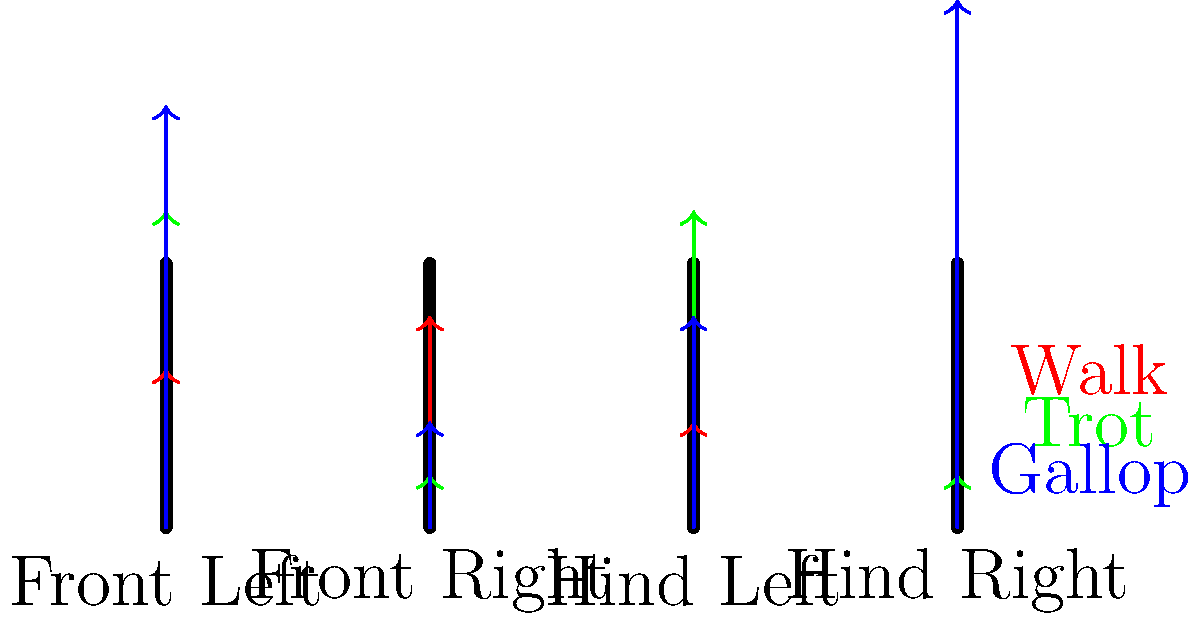As a media professional promoting a renowned jockey, you're tasked with explaining the biomechanics of horse movement to the public. Based on the force vector graphics shown for different gaits (walk, trot, and gallop), which gait places the highest peak force on a single leg, and how might this information be relevant to the jockey's riding strategy? To answer this question, we need to analyze the force vectors for each gait:

1. Walk (red vectors):
   - Forces are relatively evenly distributed across all four legs.
   - Peak force appears to be on the front right leg, but it's not significantly higher than the others.

2. Trot (green vectors):
   - Forces alternate between diagonal pairs of legs.
   - Two legs (front left and hind right) show higher forces, while the other two show lower forces.

3. Gallop (blue vectors):
   - Forces are unevenly distributed, with the highest concentration on the hind right leg.
   - The hind right leg shows the longest vector, indicating the highest peak force among all gaits.

The gallop places the highest peak force on a single leg, specifically the hind right leg. This information is relevant to the jockey's riding strategy for several reasons:

1. Performance: Understanding force distribution helps the jockey optimize the horse's stride and energy expenditure during races.

2. Injury prevention: Knowing which leg experiences the highest force allows the jockey and trainers to pay special attention to that leg's condition and implement targeted training and recovery strategies.

3. Race tactics: The jockey can use this knowledge to determine when to push for a gallop and when to maintain a more conservative gait, considering the track conditions and race distance.

4. Equipment selection: This information can guide the choice of horseshoes or other protective gear to support the legs experiencing the highest forces.

5. Public education: As a media professional, you can use this biomechanical insight to explain the jockey's decision-making process and highlight their expertise in managing the horse's performance and well-being.
Answer: Gallop; highest force on hind right leg informs jockey's strategy for performance optimization and injury prevention. 